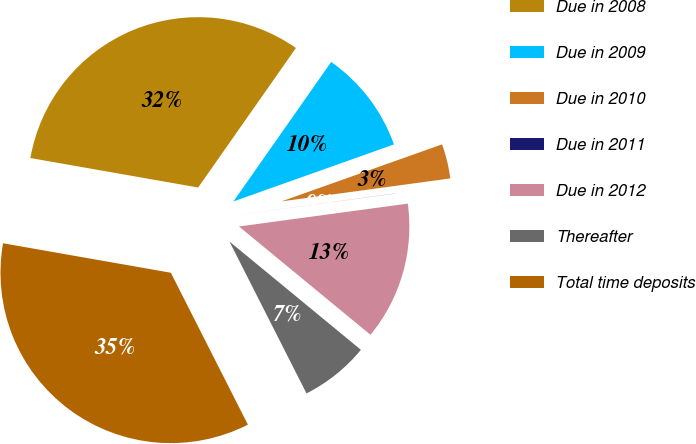Convert chart. <chart><loc_0><loc_0><loc_500><loc_500><pie_chart><fcel>Due in 2008<fcel>Due in 2009<fcel>Due in 2010<fcel>Due in 2011<fcel>Due in 2012<fcel>Thereafter<fcel>Total time deposits<nl><fcel>31.96%<fcel>9.84%<fcel>3.28%<fcel>0.01%<fcel>13.11%<fcel>6.56%<fcel>35.24%<nl></chart> 